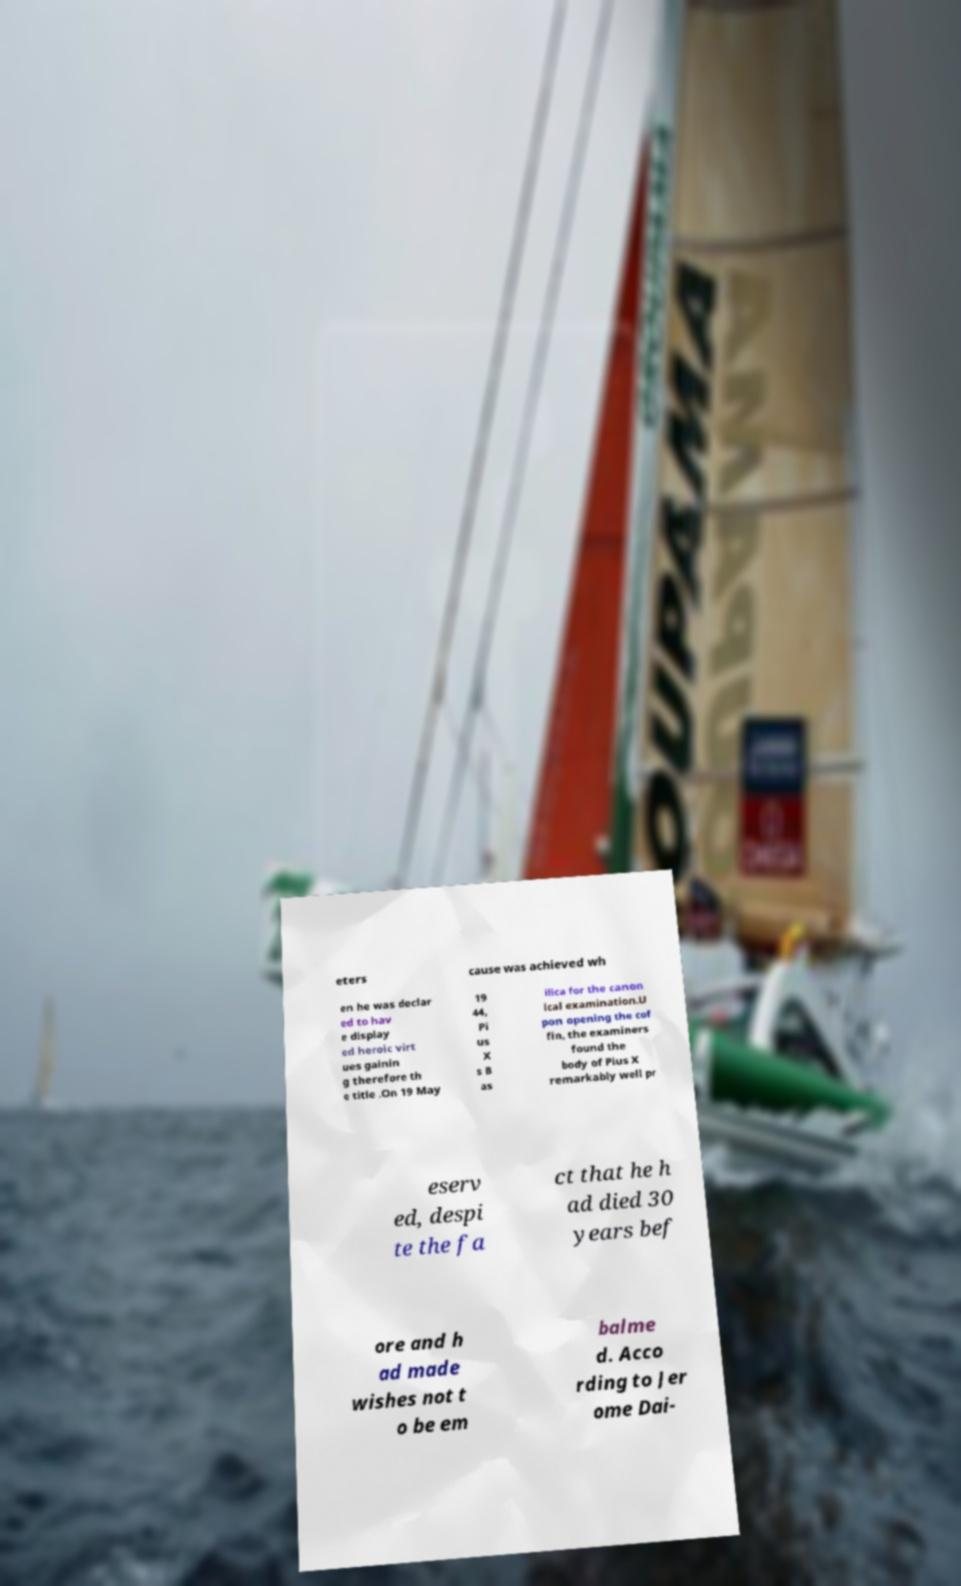Can you read and provide the text displayed in the image?This photo seems to have some interesting text. Can you extract and type it out for me? eters cause was achieved wh en he was declar ed to hav e display ed heroic virt ues gainin g therefore th e title .On 19 May 19 44, Pi us X s B as ilica for the canon ical examination.U pon opening the cof fin, the examiners found the body of Pius X remarkably well pr eserv ed, despi te the fa ct that he h ad died 30 years bef ore and h ad made wishes not t o be em balme d. Acco rding to Jer ome Dai- 